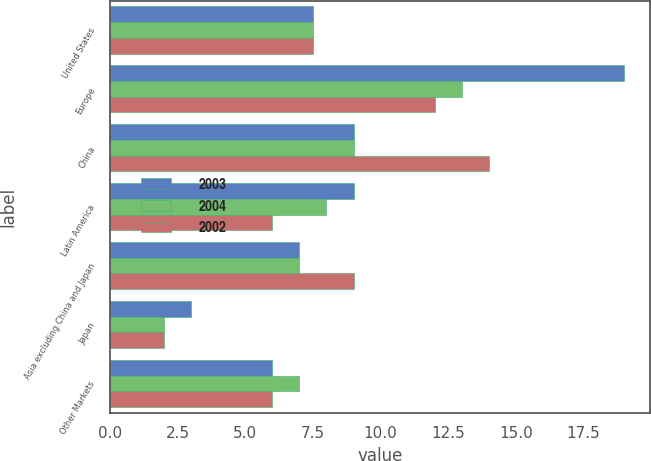Convert chart to OTSL. <chart><loc_0><loc_0><loc_500><loc_500><stacked_bar_chart><ecel><fcel>United States<fcel>Europe<fcel>China<fcel>Latin America<fcel>Asia excluding China and Japan<fcel>Japan<fcel>Other Markets<nl><fcel>2003<fcel>7.5<fcel>19<fcel>9<fcel>9<fcel>7<fcel>3<fcel>6<nl><fcel>2004<fcel>7.5<fcel>13<fcel>9<fcel>8<fcel>7<fcel>2<fcel>7<nl><fcel>2002<fcel>7.5<fcel>12<fcel>14<fcel>6<fcel>9<fcel>2<fcel>6<nl></chart> 